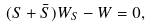Convert formula to latex. <formula><loc_0><loc_0><loc_500><loc_500>( S + \bar { S } ) W _ { S } - W = 0 ,</formula> 